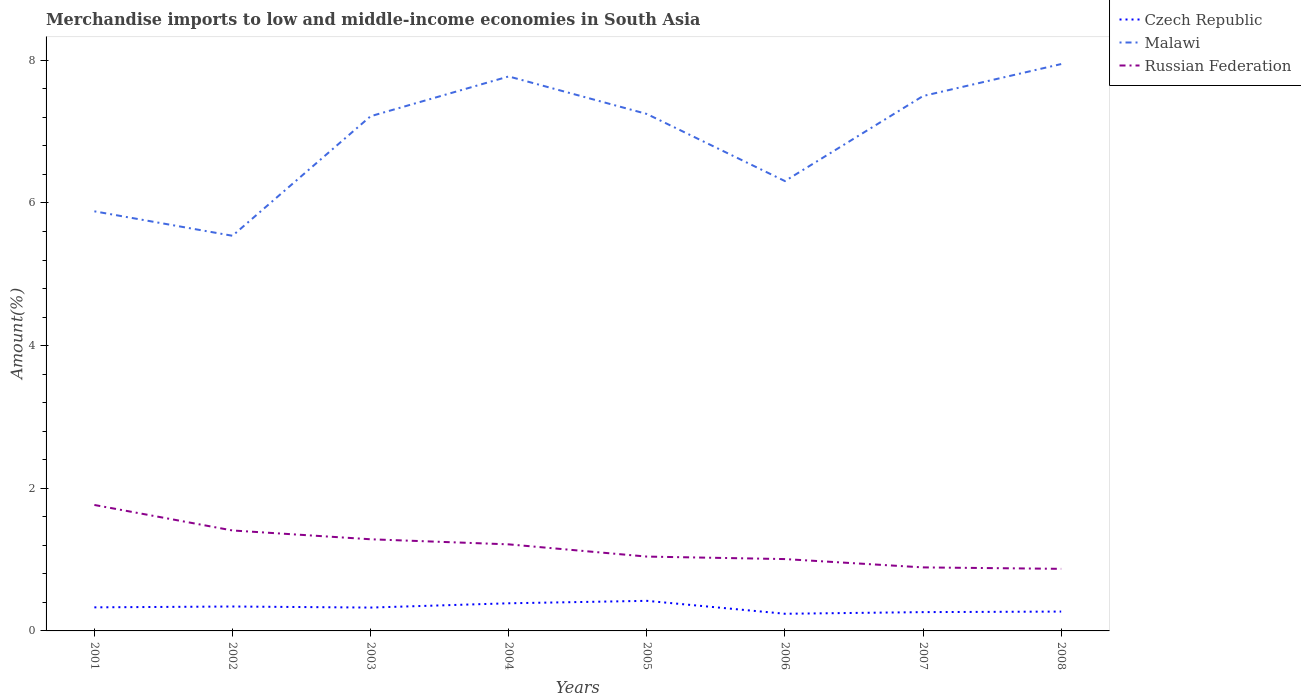Across all years, what is the maximum percentage of amount earned from merchandise imports in Czech Republic?
Your response must be concise. 0.24. What is the total percentage of amount earned from merchandise imports in Russian Federation in the graph?
Your answer should be compact. 0.39. What is the difference between the highest and the second highest percentage of amount earned from merchandise imports in Malawi?
Give a very brief answer. 2.41. What is the difference between the highest and the lowest percentage of amount earned from merchandise imports in Czech Republic?
Provide a succinct answer. 5. Are the values on the major ticks of Y-axis written in scientific E-notation?
Your answer should be compact. No. How many legend labels are there?
Your answer should be compact. 3. What is the title of the graph?
Offer a very short reply. Merchandise imports to low and middle-income economies in South Asia. What is the label or title of the X-axis?
Ensure brevity in your answer.  Years. What is the label or title of the Y-axis?
Your answer should be very brief. Amount(%). What is the Amount(%) in Czech Republic in 2001?
Keep it short and to the point. 0.33. What is the Amount(%) of Malawi in 2001?
Offer a terse response. 5.88. What is the Amount(%) in Russian Federation in 2001?
Provide a short and direct response. 1.77. What is the Amount(%) in Czech Republic in 2002?
Provide a short and direct response. 0.34. What is the Amount(%) of Malawi in 2002?
Your answer should be compact. 5.54. What is the Amount(%) in Russian Federation in 2002?
Provide a succinct answer. 1.41. What is the Amount(%) of Czech Republic in 2003?
Ensure brevity in your answer.  0.33. What is the Amount(%) of Malawi in 2003?
Ensure brevity in your answer.  7.22. What is the Amount(%) in Russian Federation in 2003?
Your answer should be very brief. 1.29. What is the Amount(%) of Czech Republic in 2004?
Ensure brevity in your answer.  0.39. What is the Amount(%) of Malawi in 2004?
Your answer should be compact. 7.77. What is the Amount(%) of Russian Federation in 2004?
Provide a short and direct response. 1.21. What is the Amount(%) in Czech Republic in 2005?
Provide a succinct answer. 0.42. What is the Amount(%) in Malawi in 2005?
Your answer should be very brief. 7.25. What is the Amount(%) in Russian Federation in 2005?
Keep it short and to the point. 1.04. What is the Amount(%) of Czech Republic in 2006?
Ensure brevity in your answer.  0.24. What is the Amount(%) in Malawi in 2006?
Offer a terse response. 6.31. What is the Amount(%) in Russian Federation in 2006?
Provide a succinct answer. 1.01. What is the Amount(%) of Czech Republic in 2007?
Offer a very short reply. 0.26. What is the Amount(%) of Malawi in 2007?
Offer a very short reply. 7.5. What is the Amount(%) in Russian Federation in 2007?
Make the answer very short. 0.89. What is the Amount(%) in Czech Republic in 2008?
Keep it short and to the point. 0.27. What is the Amount(%) of Malawi in 2008?
Your answer should be compact. 7.95. What is the Amount(%) of Russian Federation in 2008?
Offer a very short reply. 0.87. Across all years, what is the maximum Amount(%) in Czech Republic?
Your answer should be very brief. 0.42. Across all years, what is the maximum Amount(%) in Malawi?
Keep it short and to the point. 7.95. Across all years, what is the maximum Amount(%) in Russian Federation?
Make the answer very short. 1.77. Across all years, what is the minimum Amount(%) of Czech Republic?
Your answer should be very brief. 0.24. Across all years, what is the minimum Amount(%) in Malawi?
Provide a succinct answer. 5.54. Across all years, what is the minimum Amount(%) of Russian Federation?
Your answer should be compact. 0.87. What is the total Amount(%) of Czech Republic in the graph?
Offer a very short reply. 2.59. What is the total Amount(%) of Malawi in the graph?
Ensure brevity in your answer.  55.42. What is the total Amount(%) of Russian Federation in the graph?
Offer a terse response. 9.48. What is the difference between the Amount(%) in Czech Republic in 2001 and that in 2002?
Ensure brevity in your answer.  -0.01. What is the difference between the Amount(%) of Malawi in 2001 and that in 2002?
Your answer should be very brief. 0.34. What is the difference between the Amount(%) of Russian Federation in 2001 and that in 2002?
Your response must be concise. 0.36. What is the difference between the Amount(%) of Czech Republic in 2001 and that in 2003?
Make the answer very short. 0. What is the difference between the Amount(%) of Malawi in 2001 and that in 2003?
Provide a short and direct response. -1.33. What is the difference between the Amount(%) in Russian Federation in 2001 and that in 2003?
Ensure brevity in your answer.  0.48. What is the difference between the Amount(%) of Czech Republic in 2001 and that in 2004?
Provide a succinct answer. -0.06. What is the difference between the Amount(%) in Malawi in 2001 and that in 2004?
Offer a terse response. -1.89. What is the difference between the Amount(%) in Russian Federation in 2001 and that in 2004?
Provide a short and direct response. 0.55. What is the difference between the Amount(%) of Czech Republic in 2001 and that in 2005?
Offer a very short reply. -0.09. What is the difference between the Amount(%) in Malawi in 2001 and that in 2005?
Give a very brief answer. -1.36. What is the difference between the Amount(%) in Russian Federation in 2001 and that in 2005?
Your response must be concise. 0.72. What is the difference between the Amount(%) in Czech Republic in 2001 and that in 2006?
Your response must be concise. 0.09. What is the difference between the Amount(%) of Malawi in 2001 and that in 2006?
Offer a terse response. -0.42. What is the difference between the Amount(%) in Russian Federation in 2001 and that in 2006?
Provide a succinct answer. 0.76. What is the difference between the Amount(%) of Czech Republic in 2001 and that in 2007?
Provide a succinct answer. 0.07. What is the difference between the Amount(%) of Malawi in 2001 and that in 2007?
Your answer should be compact. -1.62. What is the difference between the Amount(%) in Russian Federation in 2001 and that in 2007?
Ensure brevity in your answer.  0.88. What is the difference between the Amount(%) in Czech Republic in 2001 and that in 2008?
Provide a succinct answer. 0.06. What is the difference between the Amount(%) of Malawi in 2001 and that in 2008?
Give a very brief answer. -2.06. What is the difference between the Amount(%) in Russian Federation in 2001 and that in 2008?
Keep it short and to the point. 0.9. What is the difference between the Amount(%) of Czech Republic in 2002 and that in 2003?
Give a very brief answer. 0.01. What is the difference between the Amount(%) in Malawi in 2002 and that in 2003?
Your answer should be very brief. -1.68. What is the difference between the Amount(%) of Russian Federation in 2002 and that in 2003?
Keep it short and to the point. 0.12. What is the difference between the Amount(%) in Czech Republic in 2002 and that in 2004?
Make the answer very short. -0.05. What is the difference between the Amount(%) in Malawi in 2002 and that in 2004?
Your response must be concise. -2.23. What is the difference between the Amount(%) of Russian Federation in 2002 and that in 2004?
Your answer should be very brief. 0.19. What is the difference between the Amount(%) of Czech Republic in 2002 and that in 2005?
Your response must be concise. -0.08. What is the difference between the Amount(%) of Malawi in 2002 and that in 2005?
Offer a terse response. -1.71. What is the difference between the Amount(%) of Russian Federation in 2002 and that in 2005?
Make the answer very short. 0.37. What is the difference between the Amount(%) of Czech Republic in 2002 and that in 2006?
Ensure brevity in your answer.  0.1. What is the difference between the Amount(%) in Malawi in 2002 and that in 2006?
Provide a succinct answer. -0.77. What is the difference between the Amount(%) in Russian Federation in 2002 and that in 2006?
Give a very brief answer. 0.4. What is the difference between the Amount(%) in Czech Republic in 2002 and that in 2007?
Give a very brief answer. 0.08. What is the difference between the Amount(%) of Malawi in 2002 and that in 2007?
Give a very brief answer. -1.96. What is the difference between the Amount(%) in Russian Federation in 2002 and that in 2007?
Your response must be concise. 0.52. What is the difference between the Amount(%) in Czech Republic in 2002 and that in 2008?
Offer a very short reply. 0.07. What is the difference between the Amount(%) in Malawi in 2002 and that in 2008?
Keep it short and to the point. -2.41. What is the difference between the Amount(%) of Russian Federation in 2002 and that in 2008?
Your answer should be compact. 0.54. What is the difference between the Amount(%) of Czech Republic in 2003 and that in 2004?
Your response must be concise. -0.06. What is the difference between the Amount(%) of Malawi in 2003 and that in 2004?
Offer a terse response. -0.56. What is the difference between the Amount(%) of Russian Federation in 2003 and that in 2004?
Offer a very short reply. 0.07. What is the difference between the Amount(%) in Czech Republic in 2003 and that in 2005?
Provide a succinct answer. -0.09. What is the difference between the Amount(%) of Malawi in 2003 and that in 2005?
Give a very brief answer. -0.03. What is the difference between the Amount(%) of Russian Federation in 2003 and that in 2005?
Give a very brief answer. 0.24. What is the difference between the Amount(%) in Czech Republic in 2003 and that in 2006?
Offer a very short reply. 0.09. What is the difference between the Amount(%) of Malawi in 2003 and that in 2006?
Keep it short and to the point. 0.91. What is the difference between the Amount(%) in Russian Federation in 2003 and that in 2006?
Your answer should be very brief. 0.28. What is the difference between the Amount(%) of Czech Republic in 2003 and that in 2007?
Provide a succinct answer. 0.06. What is the difference between the Amount(%) of Malawi in 2003 and that in 2007?
Your answer should be very brief. -0.28. What is the difference between the Amount(%) of Russian Federation in 2003 and that in 2007?
Your answer should be compact. 0.39. What is the difference between the Amount(%) of Czech Republic in 2003 and that in 2008?
Your answer should be compact. 0.06. What is the difference between the Amount(%) of Malawi in 2003 and that in 2008?
Provide a succinct answer. -0.73. What is the difference between the Amount(%) in Russian Federation in 2003 and that in 2008?
Make the answer very short. 0.41. What is the difference between the Amount(%) of Czech Republic in 2004 and that in 2005?
Give a very brief answer. -0.03. What is the difference between the Amount(%) in Malawi in 2004 and that in 2005?
Your answer should be compact. 0.53. What is the difference between the Amount(%) in Russian Federation in 2004 and that in 2005?
Keep it short and to the point. 0.17. What is the difference between the Amount(%) of Czech Republic in 2004 and that in 2006?
Provide a short and direct response. 0.15. What is the difference between the Amount(%) of Malawi in 2004 and that in 2006?
Keep it short and to the point. 1.47. What is the difference between the Amount(%) in Russian Federation in 2004 and that in 2006?
Make the answer very short. 0.21. What is the difference between the Amount(%) in Czech Republic in 2004 and that in 2007?
Provide a short and direct response. 0.12. What is the difference between the Amount(%) in Malawi in 2004 and that in 2007?
Provide a succinct answer. 0.27. What is the difference between the Amount(%) of Russian Federation in 2004 and that in 2007?
Make the answer very short. 0.32. What is the difference between the Amount(%) of Czech Republic in 2004 and that in 2008?
Provide a short and direct response. 0.12. What is the difference between the Amount(%) of Malawi in 2004 and that in 2008?
Give a very brief answer. -0.17. What is the difference between the Amount(%) in Russian Federation in 2004 and that in 2008?
Provide a succinct answer. 0.34. What is the difference between the Amount(%) of Czech Republic in 2005 and that in 2006?
Keep it short and to the point. 0.18. What is the difference between the Amount(%) in Malawi in 2005 and that in 2006?
Provide a succinct answer. 0.94. What is the difference between the Amount(%) of Russian Federation in 2005 and that in 2006?
Your response must be concise. 0.04. What is the difference between the Amount(%) in Czech Republic in 2005 and that in 2007?
Provide a short and direct response. 0.16. What is the difference between the Amount(%) of Malawi in 2005 and that in 2007?
Give a very brief answer. -0.25. What is the difference between the Amount(%) of Russian Federation in 2005 and that in 2007?
Offer a very short reply. 0.15. What is the difference between the Amount(%) in Czech Republic in 2005 and that in 2008?
Offer a very short reply. 0.15. What is the difference between the Amount(%) of Malawi in 2005 and that in 2008?
Provide a succinct answer. -0.7. What is the difference between the Amount(%) in Russian Federation in 2005 and that in 2008?
Your response must be concise. 0.17. What is the difference between the Amount(%) of Czech Republic in 2006 and that in 2007?
Provide a short and direct response. -0.02. What is the difference between the Amount(%) of Malawi in 2006 and that in 2007?
Your response must be concise. -1.19. What is the difference between the Amount(%) in Russian Federation in 2006 and that in 2007?
Provide a short and direct response. 0.12. What is the difference between the Amount(%) in Czech Republic in 2006 and that in 2008?
Your answer should be very brief. -0.03. What is the difference between the Amount(%) in Malawi in 2006 and that in 2008?
Offer a terse response. -1.64. What is the difference between the Amount(%) of Russian Federation in 2006 and that in 2008?
Make the answer very short. 0.14. What is the difference between the Amount(%) in Czech Republic in 2007 and that in 2008?
Your answer should be compact. -0.01. What is the difference between the Amount(%) in Malawi in 2007 and that in 2008?
Provide a short and direct response. -0.45. What is the difference between the Amount(%) of Russian Federation in 2007 and that in 2008?
Give a very brief answer. 0.02. What is the difference between the Amount(%) in Czech Republic in 2001 and the Amount(%) in Malawi in 2002?
Your answer should be very brief. -5.21. What is the difference between the Amount(%) of Czech Republic in 2001 and the Amount(%) of Russian Federation in 2002?
Provide a succinct answer. -1.08. What is the difference between the Amount(%) of Malawi in 2001 and the Amount(%) of Russian Federation in 2002?
Your answer should be compact. 4.47. What is the difference between the Amount(%) of Czech Republic in 2001 and the Amount(%) of Malawi in 2003?
Give a very brief answer. -6.89. What is the difference between the Amount(%) in Czech Republic in 2001 and the Amount(%) in Russian Federation in 2003?
Your answer should be very brief. -0.95. What is the difference between the Amount(%) of Malawi in 2001 and the Amount(%) of Russian Federation in 2003?
Keep it short and to the point. 4.6. What is the difference between the Amount(%) in Czech Republic in 2001 and the Amount(%) in Malawi in 2004?
Provide a succinct answer. -7.44. What is the difference between the Amount(%) in Czech Republic in 2001 and the Amount(%) in Russian Federation in 2004?
Ensure brevity in your answer.  -0.88. What is the difference between the Amount(%) in Malawi in 2001 and the Amount(%) in Russian Federation in 2004?
Provide a short and direct response. 4.67. What is the difference between the Amount(%) of Czech Republic in 2001 and the Amount(%) of Malawi in 2005?
Ensure brevity in your answer.  -6.92. What is the difference between the Amount(%) of Czech Republic in 2001 and the Amount(%) of Russian Federation in 2005?
Keep it short and to the point. -0.71. What is the difference between the Amount(%) in Malawi in 2001 and the Amount(%) in Russian Federation in 2005?
Ensure brevity in your answer.  4.84. What is the difference between the Amount(%) of Czech Republic in 2001 and the Amount(%) of Malawi in 2006?
Keep it short and to the point. -5.98. What is the difference between the Amount(%) of Czech Republic in 2001 and the Amount(%) of Russian Federation in 2006?
Your answer should be very brief. -0.68. What is the difference between the Amount(%) in Malawi in 2001 and the Amount(%) in Russian Federation in 2006?
Ensure brevity in your answer.  4.88. What is the difference between the Amount(%) of Czech Republic in 2001 and the Amount(%) of Malawi in 2007?
Provide a succinct answer. -7.17. What is the difference between the Amount(%) of Czech Republic in 2001 and the Amount(%) of Russian Federation in 2007?
Your answer should be compact. -0.56. What is the difference between the Amount(%) in Malawi in 2001 and the Amount(%) in Russian Federation in 2007?
Give a very brief answer. 4.99. What is the difference between the Amount(%) in Czech Republic in 2001 and the Amount(%) in Malawi in 2008?
Ensure brevity in your answer.  -7.62. What is the difference between the Amount(%) in Czech Republic in 2001 and the Amount(%) in Russian Federation in 2008?
Your response must be concise. -0.54. What is the difference between the Amount(%) in Malawi in 2001 and the Amount(%) in Russian Federation in 2008?
Your response must be concise. 5.01. What is the difference between the Amount(%) in Czech Republic in 2002 and the Amount(%) in Malawi in 2003?
Provide a succinct answer. -6.87. What is the difference between the Amount(%) in Czech Republic in 2002 and the Amount(%) in Russian Federation in 2003?
Ensure brevity in your answer.  -0.94. What is the difference between the Amount(%) in Malawi in 2002 and the Amount(%) in Russian Federation in 2003?
Keep it short and to the point. 4.26. What is the difference between the Amount(%) of Czech Republic in 2002 and the Amount(%) of Malawi in 2004?
Your response must be concise. -7.43. What is the difference between the Amount(%) in Czech Republic in 2002 and the Amount(%) in Russian Federation in 2004?
Make the answer very short. -0.87. What is the difference between the Amount(%) of Malawi in 2002 and the Amount(%) of Russian Federation in 2004?
Provide a short and direct response. 4.33. What is the difference between the Amount(%) in Czech Republic in 2002 and the Amount(%) in Malawi in 2005?
Keep it short and to the point. -6.91. What is the difference between the Amount(%) of Czech Republic in 2002 and the Amount(%) of Russian Federation in 2005?
Provide a succinct answer. -0.7. What is the difference between the Amount(%) in Malawi in 2002 and the Amount(%) in Russian Federation in 2005?
Make the answer very short. 4.5. What is the difference between the Amount(%) of Czech Republic in 2002 and the Amount(%) of Malawi in 2006?
Ensure brevity in your answer.  -5.96. What is the difference between the Amount(%) in Czech Republic in 2002 and the Amount(%) in Russian Federation in 2006?
Offer a very short reply. -0.67. What is the difference between the Amount(%) of Malawi in 2002 and the Amount(%) of Russian Federation in 2006?
Keep it short and to the point. 4.53. What is the difference between the Amount(%) in Czech Republic in 2002 and the Amount(%) in Malawi in 2007?
Your answer should be compact. -7.16. What is the difference between the Amount(%) in Czech Republic in 2002 and the Amount(%) in Russian Federation in 2007?
Ensure brevity in your answer.  -0.55. What is the difference between the Amount(%) in Malawi in 2002 and the Amount(%) in Russian Federation in 2007?
Ensure brevity in your answer.  4.65. What is the difference between the Amount(%) of Czech Republic in 2002 and the Amount(%) of Malawi in 2008?
Your answer should be very brief. -7.61. What is the difference between the Amount(%) in Czech Republic in 2002 and the Amount(%) in Russian Federation in 2008?
Keep it short and to the point. -0.53. What is the difference between the Amount(%) of Malawi in 2002 and the Amount(%) of Russian Federation in 2008?
Keep it short and to the point. 4.67. What is the difference between the Amount(%) of Czech Republic in 2003 and the Amount(%) of Malawi in 2004?
Your answer should be very brief. -7.45. What is the difference between the Amount(%) of Czech Republic in 2003 and the Amount(%) of Russian Federation in 2004?
Keep it short and to the point. -0.89. What is the difference between the Amount(%) in Malawi in 2003 and the Amount(%) in Russian Federation in 2004?
Your answer should be very brief. 6. What is the difference between the Amount(%) of Czech Republic in 2003 and the Amount(%) of Malawi in 2005?
Your answer should be very brief. -6.92. What is the difference between the Amount(%) in Czech Republic in 2003 and the Amount(%) in Russian Federation in 2005?
Make the answer very short. -0.71. What is the difference between the Amount(%) of Malawi in 2003 and the Amount(%) of Russian Federation in 2005?
Make the answer very short. 6.17. What is the difference between the Amount(%) in Czech Republic in 2003 and the Amount(%) in Malawi in 2006?
Your answer should be compact. -5.98. What is the difference between the Amount(%) of Czech Republic in 2003 and the Amount(%) of Russian Federation in 2006?
Offer a terse response. -0.68. What is the difference between the Amount(%) of Malawi in 2003 and the Amount(%) of Russian Federation in 2006?
Your answer should be very brief. 6.21. What is the difference between the Amount(%) of Czech Republic in 2003 and the Amount(%) of Malawi in 2007?
Provide a succinct answer. -7.17. What is the difference between the Amount(%) in Czech Republic in 2003 and the Amount(%) in Russian Federation in 2007?
Offer a terse response. -0.56. What is the difference between the Amount(%) in Malawi in 2003 and the Amount(%) in Russian Federation in 2007?
Offer a very short reply. 6.33. What is the difference between the Amount(%) of Czech Republic in 2003 and the Amount(%) of Malawi in 2008?
Your answer should be very brief. -7.62. What is the difference between the Amount(%) of Czech Republic in 2003 and the Amount(%) of Russian Federation in 2008?
Make the answer very short. -0.54. What is the difference between the Amount(%) in Malawi in 2003 and the Amount(%) in Russian Federation in 2008?
Keep it short and to the point. 6.35. What is the difference between the Amount(%) of Czech Republic in 2004 and the Amount(%) of Malawi in 2005?
Ensure brevity in your answer.  -6.86. What is the difference between the Amount(%) of Czech Republic in 2004 and the Amount(%) of Russian Federation in 2005?
Your response must be concise. -0.65. What is the difference between the Amount(%) of Malawi in 2004 and the Amount(%) of Russian Federation in 2005?
Offer a very short reply. 6.73. What is the difference between the Amount(%) in Czech Republic in 2004 and the Amount(%) in Malawi in 2006?
Provide a succinct answer. -5.92. What is the difference between the Amount(%) in Czech Republic in 2004 and the Amount(%) in Russian Federation in 2006?
Give a very brief answer. -0.62. What is the difference between the Amount(%) of Malawi in 2004 and the Amount(%) of Russian Federation in 2006?
Make the answer very short. 6.77. What is the difference between the Amount(%) in Czech Republic in 2004 and the Amount(%) in Malawi in 2007?
Your response must be concise. -7.11. What is the difference between the Amount(%) of Czech Republic in 2004 and the Amount(%) of Russian Federation in 2007?
Your answer should be compact. -0.5. What is the difference between the Amount(%) in Malawi in 2004 and the Amount(%) in Russian Federation in 2007?
Your answer should be very brief. 6.88. What is the difference between the Amount(%) in Czech Republic in 2004 and the Amount(%) in Malawi in 2008?
Your response must be concise. -7.56. What is the difference between the Amount(%) of Czech Republic in 2004 and the Amount(%) of Russian Federation in 2008?
Provide a short and direct response. -0.48. What is the difference between the Amount(%) of Malawi in 2004 and the Amount(%) of Russian Federation in 2008?
Provide a short and direct response. 6.9. What is the difference between the Amount(%) in Czech Republic in 2005 and the Amount(%) in Malawi in 2006?
Your response must be concise. -5.89. What is the difference between the Amount(%) in Czech Republic in 2005 and the Amount(%) in Russian Federation in 2006?
Offer a terse response. -0.59. What is the difference between the Amount(%) of Malawi in 2005 and the Amount(%) of Russian Federation in 2006?
Offer a terse response. 6.24. What is the difference between the Amount(%) in Czech Republic in 2005 and the Amount(%) in Malawi in 2007?
Make the answer very short. -7.08. What is the difference between the Amount(%) of Czech Republic in 2005 and the Amount(%) of Russian Federation in 2007?
Offer a very short reply. -0.47. What is the difference between the Amount(%) of Malawi in 2005 and the Amount(%) of Russian Federation in 2007?
Your response must be concise. 6.36. What is the difference between the Amount(%) of Czech Republic in 2005 and the Amount(%) of Malawi in 2008?
Give a very brief answer. -7.53. What is the difference between the Amount(%) of Czech Republic in 2005 and the Amount(%) of Russian Federation in 2008?
Provide a succinct answer. -0.45. What is the difference between the Amount(%) in Malawi in 2005 and the Amount(%) in Russian Federation in 2008?
Offer a very short reply. 6.38. What is the difference between the Amount(%) of Czech Republic in 2006 and the Amount(%) of Malawi in 2007?
Keep it short and to the point. -7.26. What is the difference between the Amount(%) in Czech Republic in 2006 and the Amount(%) in Russian Federation in 2007?
Your answer should be very brief. -0.65. What is the difference between the Amount(%) in Malawi in 2006 and the Amount(%) in Russian Federation in 2007?
Provide a short and direct response. 5.42. What is the difference between the Amount(%) in Czech Republic in 2006 and the Amount(%) in Malawi in 2008?
Offer a terse response. -7.71. What is the difference between the Amount(%) in Czech Republic in 2006 and the Amount(%) in Russian Federation in 2008?
Make the answer very short. -0.63. What is the difference between the Amount(%) of Malawi in 2006 and the Amount(%) of Russian Federation in 2008?
Give a very brief answer. 5.44. What is the difference between the Amount(%) of Czech Republic in 2007 and the Amount(%) of Malawi in 2008?
Give a very brief answer. -7.68. What is the difference between the Amount(%) in Czech Republic in 2007 and the Amount(%) in Russian Federation in 2008?
Keep it short and to the point. -0.61. What is the difference between the Amount(%) in Malawi in 2007 and the Amount(%) in Russian Federation in 2008?
Provide a succinct answer. 6.63. What is the average Amount(%) of Czech Republic per year?
Your answer should be compact. 0.32. What is the average Amount(%) in Malawi per year?
Offer a very short reply. 6.93. What is the average Amount(%) in Russian Federation per year?
Offer a very short reply. 1.19. In the year 2001, what is the difference between the Amount(%) of Czech Republic and Amount(%) of Malawi?
Provide a succinct answer. -5.55. In the year 2001, what is the difference between the Amount(%) of Czech Republic and Amount(%) of Russian Federation?
Your answer should be very brief. -1.44. In the year 2001, what is the difference between the Amount(%) of Malawi and Amount(%) of Russian Federation?
Make the answer very short. 4.12. In the year 2002, what is the difference between the Amount(%) in Czech Republic and Amount(%) in Malawi?
Provide a short and direct response. -5.2. In the year 2002, what is the difference between the Amount(%) in Czech Republic and Amount(%) in Russian Federation?
Keep it short and to the point. -1.07. In the year 2002, what is the difference between the Amount(%) in Malawi and Amount(%) in Russian Federation?
Your answer should be compact. 4.13. In the year 2003, what is the difference between the Amount(%) of Czech Republic and Amount(%) of Malawi?
Your answer should be very brief. -6.89. In the year 2003, what is the difference between the Amount(%) in Czech Republic and Amount(%) in Russian Federation?
Provide a succinct answer. -0.96. In the year 2003, what is the difference between the Amount(%) in Malawi and Amount(%) in Russian Federation?
Provide a succinct answer. 5.93. In the year 2004, what is the difference between the Amount(%) of Czech Republic and Amount(%) of Malawi?
Offer a very short reply. -7.39. In the year 2004, what is the difference between the Amount(%) of Czech Republic and Amount(%) of Russian Federation?
Keep it short and to the point. -0.83. In the year 2004, what is the difference between the Amount(%) in Malawi and Amount(%) in Russian Federation?
Offer a terse response. 6.56. In the year 2005, what is the difference between the Amount(%) of Czech Republic and Amount(%) of Malawi?
Ensure brevity in your answer.  -6.83. In the year 2005, what is the difference between the Amount(%) of Czech Republic and Amount(%) of Russian Federation?
Your answer should be very brief. -0.62. In the year 2005, what is the difference between the Amount(%) of Malawi and Amount(%) of Russian Federation?
Give a very brief answer. 6.21. In the year 2006, what is the difference between the Amount(%) of Czech Republic and Amount(%) of Malawi?
Your answer should be very brief. -6.07. In the year 2006, what is the difference between the Amount(%) in Czech Republic and Amount(%) in Russian Federation?
Keep it short and to the point. -0.77. In the year 2006, what is the difference between the Amount(%) of Malawi and Amount(%) of Russian Federation?
Provide a short and direct response. 5.3. In the year 2007, what is the difference between the Amount(%) of Czech Republic and Amount(%) of Malawi?
Ensure brevity in your answer.  -7.24. In the year 2007, what is the difference between the Amount(%) of Czech Republic and Amount(%) of Russian Federation?
Ensure brevity in your answer.  -0.63. In the year 2007, what is the difference between the Amount(%) of Malawi and Amount(%) of Russian Federation?
Offer a terse response. 6.61. In the year 2008, what is the difference between the Amount(%) of Czech Republic and Amount(%) of Malawi?
Your answer should be very brief. -7.68. In the year 2008, what is the difference between the Amount(%) in Czech Republic and Amount(%) in Russian Federation?
Keep it short and to the point. -0.6. In the year 2008, what is the difference between the Amount(%) in Malawi and Amount(%) in Russian Federation?
Your answer should be very brief. 7.08. What is the ratio of the Amount(%) in Czech Republic in 2001 to that in 2002?
Offer a terse response. 0.97. What is the ratio of the Amount(%) in Malawi in 2001 to that in 2002?
Your answer should be compact. 1.06. What is the ratio of the Amount(%) of Russian Federation in 2001 to that in 2002?
Make the answer very short. 1.25. What is the ratio of the Amount(%) of Czech Republic in 2001 to that in 2003?
Offer a terse response. 1.01. What is the ratio of the Amount(%) of Malawi in 2001 to that in 2003?
Provide a short and direct response. 0.82. What is the ratio of the Amount(%) in Russian Federation in 2001 to that in 2003?
Your answer should be compact. 1.37. What is the ratio of the Amount(%) of Czech Republic in 2001 to that in 2004?
Offer a terse response. 0.85. What is the ratio of the Amount(%) in Malawi in 2001 to that in 2004?
Your answer should be compact. 0.76. What is the ratio of the Amount(%) in Russian Federation in 2001 to that in 2004?
Make the answer very short. 1.46. What is the ratio of the Amount(%) of Czech Republic in 2001 to that in 2005?
Make the answer very short. 0.78. What is the ratio of the Amount(%) in Malawi in 2001 to that in 2005?
Your answer should be very brief. 0.81. What is the ratio of the Amount(%) in Russian Federation in 2001 to that in 2005?
Provide a short and direct response. 1.69. What is the ratio of the Amount(%) in Czech Republic in 2001 to that in 2006?
Offer a very short reply. 1.37. What is the ratio of the Amount(%) in Malawi in 2001 to that in 2006?
Make the answer very short. 0.93. What is the ratio of the Amount(%) of Russian Federation in 2001 to that in 2006?
Your answer should be very brief. 1.75. What is the ratio of the Amount(%) in Czech Republic in 2001 to that in 2007?
Offer a very short reply. 1.25. What is the ratio of the Amount(%) in Malawi in 2001 to that in 2007?
Your answer should be compact. 0.78. What is the ratio of the Amount(%) of Russian Federation in 2001 to that in 2007?
Provide a succinct answer. 1.98. What is the ratio of the Amount(%) of Czech Republic in 2001 to that in 2008?
Ensure brevity in your answer.  1.22. What is the ratio of the Amount(%) in Malawi in 2001 to that in 2008?
Your response must be concise. 0.74. What is the ratio of the Amount(%) in Russian Federation in 2001 to that in 2008?
Ensure brevity in your answer.  2.03. What is the ratio of the Amount(%) of Czech Republic in 2002 to that in 2003?
Give a very brief answer. 1.05. What is the ratio of the Amount(%) of Malawi in 2002 to that in 2003?
Your response must be concise. 0.77. What is the ratio of the Amount(%) in Russian Federation in 2002 to that in 2003?
Offer a very short reply. 1.1. What is the ratio of the Amount(%) in Czech Republic in 2002 to that in 2004?
Ensure brevity in your answer.  0.88. What is the ratio of the Amount(%) in Malawi in 2002 to that in 2004?
Your answer should be very brief. 0.71. What is the ratio of the Amount(%) of Russian Federation in 2002 to that in 2004?
Provide a succinct answer. 1.16. What is the ratio of the Amount(%) in Czech Republic in 2002 to that in 2005?
Your answer should be very brief. 0.81. What is the ratio of the Amount(%) of Malawi in 2002 to that in 2005?
Your response must be concise. 0.76. What is the ratio of the Amount(%) of Russian Federation in 2002 to that in 2005?
Provide a succinct answer. 1.35. What is the ratio of the Amount(%) in Czech Republic in 2002 to that in 2006?
Provide a succinct answer. 1.42. What is the ratio of the Amount(%) in Malawi in 2002 to that in 2006?
Provide a short and direct response. 0.88. What is the ratio of the Amount(%) of Russian Federation in 2002 to that in 2006?
Keep it short and to the point. 1.4. What is the ratio of the Amount(%) in Czech Republic in 2002 to that in 2007?
Offer a terse response. 1.3. What is the ratio of the Amount(%) of Malawi in 2002 to that in 2007?
Make the answer very short. 0.74. What is the ratio of the Amount(%) in Russian Federation in 2002 to that in 2007?
Ensure brevity in your answer.  1.58. What is the ratio of the Amount(%) in Czech Republic in 2002 to that in 2008?
Make the answer very short. 1.26. What is the ratio of the Amount(%) in Malawi in 2002 to that in 2008?
Your response must be concise. 0.7. What is the ratio of the Amount(%) in Russian Federation in 2002 to that in 2008?
Offer a very short reply. 1.62. What is the ratio of the Amount(%) of Czech Republic in 2003 to that in 2004?
Your response must be concise. 0.84. What is the ratio of the Amount(%) in Malawi in 2003 to that in 2004?
Offer a very short reply. 0.93. What is the ratio of the Amount(%) of Russian Federation in 2003 to that in 2004?
Offer a terse response. 1.06. What is the ratio of the Amount(%) of Czech Republic in 2003 to that in 2005?
Offer a terse response. 0.78. What is the ratio of the Amount(%) in Malawi in 2003 to that in 2005?
Ensure brevity in your answer.  1. What is the ratio of the Amount(%) of Russian Federation in 2003 to that in 2005?
Provide a short and direct response. 1.23. What is the ratio of the Amount(%) of Czech Republic in 2003 to that in 2006?
Make the answer very short. 1.36. What is the ratio of the Amount(%) in Malawi in 2003 to that in 2006?
Keep it short and to the point. 1.14. What is the ratio of the Amount(%) in Russian Federation in 2003 to that in 2006?
Provide a short and direct response. 1.28. What is the ratio of the Amount(%) of Czech Republic in 2003 to that in 2007?
Offer a terse response. 1.24. What is the ratio of the Amount(%) of Malawi in 2003 to that in 2007?
Make the answer very short. 0.96. What is the ratio of the Amount(%) in Russian Federation in 2003 to that in 2007?
Give a very brief answer. 1.44. What is the ratio of the Amount(%) of Czech Republic in 2003 to that in 2008?
Provide a short and direct response. 1.21. What is the ratio of the Amount(%) in Malawi in 2003 to that in 2008?
Offer a very short reply. 0.91. What is the ratio of the Amount(%) in Russian Federation in 2003 to that in 2008?
Give a very brief answer. 1.48. What is the ratio of the Amount(%) of Czech Republic in 2004 to that in 2005?
Make the answer very short. 0.92. What is the ratio of the Amount(%) of Malawi in 2004 to that in 2005?
Your answer should be compact. 1.07. What is the ratio of the Amount(%) of Russian Federation in 2004 to that in 2005?
Provide a short and direct response. 1.16. What is the ratio of the Amount(%) in Czech Republic in 2004 to that in 2006?
Ensure brevity in your answer.  1.61. What is the ratio of the Amount(%) of Malawi in 2004 to that in 2006?
Offer a very short reply. 1.23. What is the ratio of the Amount(%) in Russian Federation in 2004 to that in 2006?
Keep it short and to the point. 1.2. What is the ratio of the Amount(%) in Czech Republic in 2004 to that in 2007?
Give a very brief answer. 1.47. What is the ratio of the Amount(%) in Malawi in 2004 to that in 2007?
Make the answer very short. 1.04. What is the ratio of the Amount(%) in Russian Federation in 2004 to that in 2007?
Your answer should be very brief. 1.36. What is the ratio of the Amount(%) of Czech Republic in 2004 to that in 2008?
Keep it short and to the point. 1.43. What is the ratio of the Amount(%) in Malawi in 2004 to that in 2008?
Make the answer very short. 0.98. What is the ratio of the Amount(%) in Russian Federation in 2004 to that in 2008?
Ensure brevity in your answer.  1.39. What is the ratio of the Amount(%) in Czech Republic in 2005 to that in 2006?
Your answer should be compact. 1.75. What is the ratio of the Amount(%) in Malawi in 2005 to that in 2006?
Give a very brief answer. 1.15. What is the ratio of the Amount(%) of Russian Federation in 2005 to that in 2006?
Keep it short and to the point. 1.03. What is the ratio of the Amount(%) in Czech Republic in 2005 to that in 2007?
Your answer should be very brief. 1.6. What is the ratio of the Amount(%) in Malawi in 2005 to that in 2007?
Your response must be concise. 0.97. What is the ratio of the Amount(%) in Russian Federation in 2005 to that in 2007?
Make the answer very short. 1.17. What is the ratio of the Amount(%) of Czech Republic in 2005 to that in 2008?
Make the answer very short. 1.55. What is the ratio of the Amount(%) of Malawi in 2005 to that in 2008?
Keep it short and to the point. 0.91. What is the ratio of the Amount(%) in Russian Federation in 2005 to that in 2008?
Your answer should be compact. 1.2. What is the ratio of the Amount(%) in Czech Republic in 2006 to that in 2007?
Give a very brief answer. 0.91. What is the ratio of the Amount(%) of Malawi in 2006 to that in 2007?
Make the answer very short. 0.84. What is the ratio of the Amount(%) in Russian Federation in 2006 to that in 2007?
Ensure brevity in your answer.  1.13. What is the ratio of the Amount(%) in Czech Republic in 2006 to that in 2008?
Provide a short and direct response. 0.89. What is the ratio of the Amount(%) of Malawi in 2006 to that in 2008?
Ensure brevity in your answer.  0.79. What is the ratio of the Amount(%) in Russian Federation in 2006 to that in 2008?
Your answer should be very brief. 1.16. What is the ratio of the Amount(%) in Czech Republic in 2007 to that in 2008?
Give a very brief answer. 0.97. What is the ratio of the Amount(%) of Malawi in 2007 to that in 2008?
Provide a short and direct response. 0.94. What is the ratio of the Amount(%) in Russian Federation in 2007 to that in 2008?
Give a very brief answer. 1.02. What is the difference between the highest and the second highest Amount(%) in Czech Republic?
Offer a very short reply. 0.03. What is the difference between the highest and the second highest Amount(%) of Malawi?
Keep it short and to the point. 0.17. What is the difference between the highest and the second highest Amount(%) in Russian Federation?
Ensure brevity in your answer.  0.36. What is the difference between the highest and the lowest Amount(%) of Czech Republic?
Provide a succinct answer. 0.18. What is the difference between the highest and the lowest Amount(%) in Malawi?
Your answer should be very brief. 2.41. What is the difference between the highest and the lowest Amount(%) of Russian Federation?
Keep it short and to the point. 0.9. 